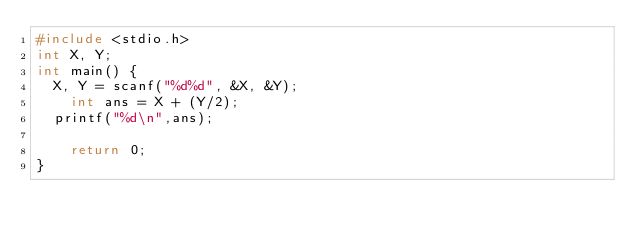Convert code to text. <code><loc_0><loc_0><loc_500><loc_500><_C++_>#include <stdio.h>
int X, Y;
int main() {
	X, Y = scanf("%d%d", &X, &Y);
  	int ans = X + (Y/2);
	printf("%d\n",ans);
  
  	return 0;
}</code> 